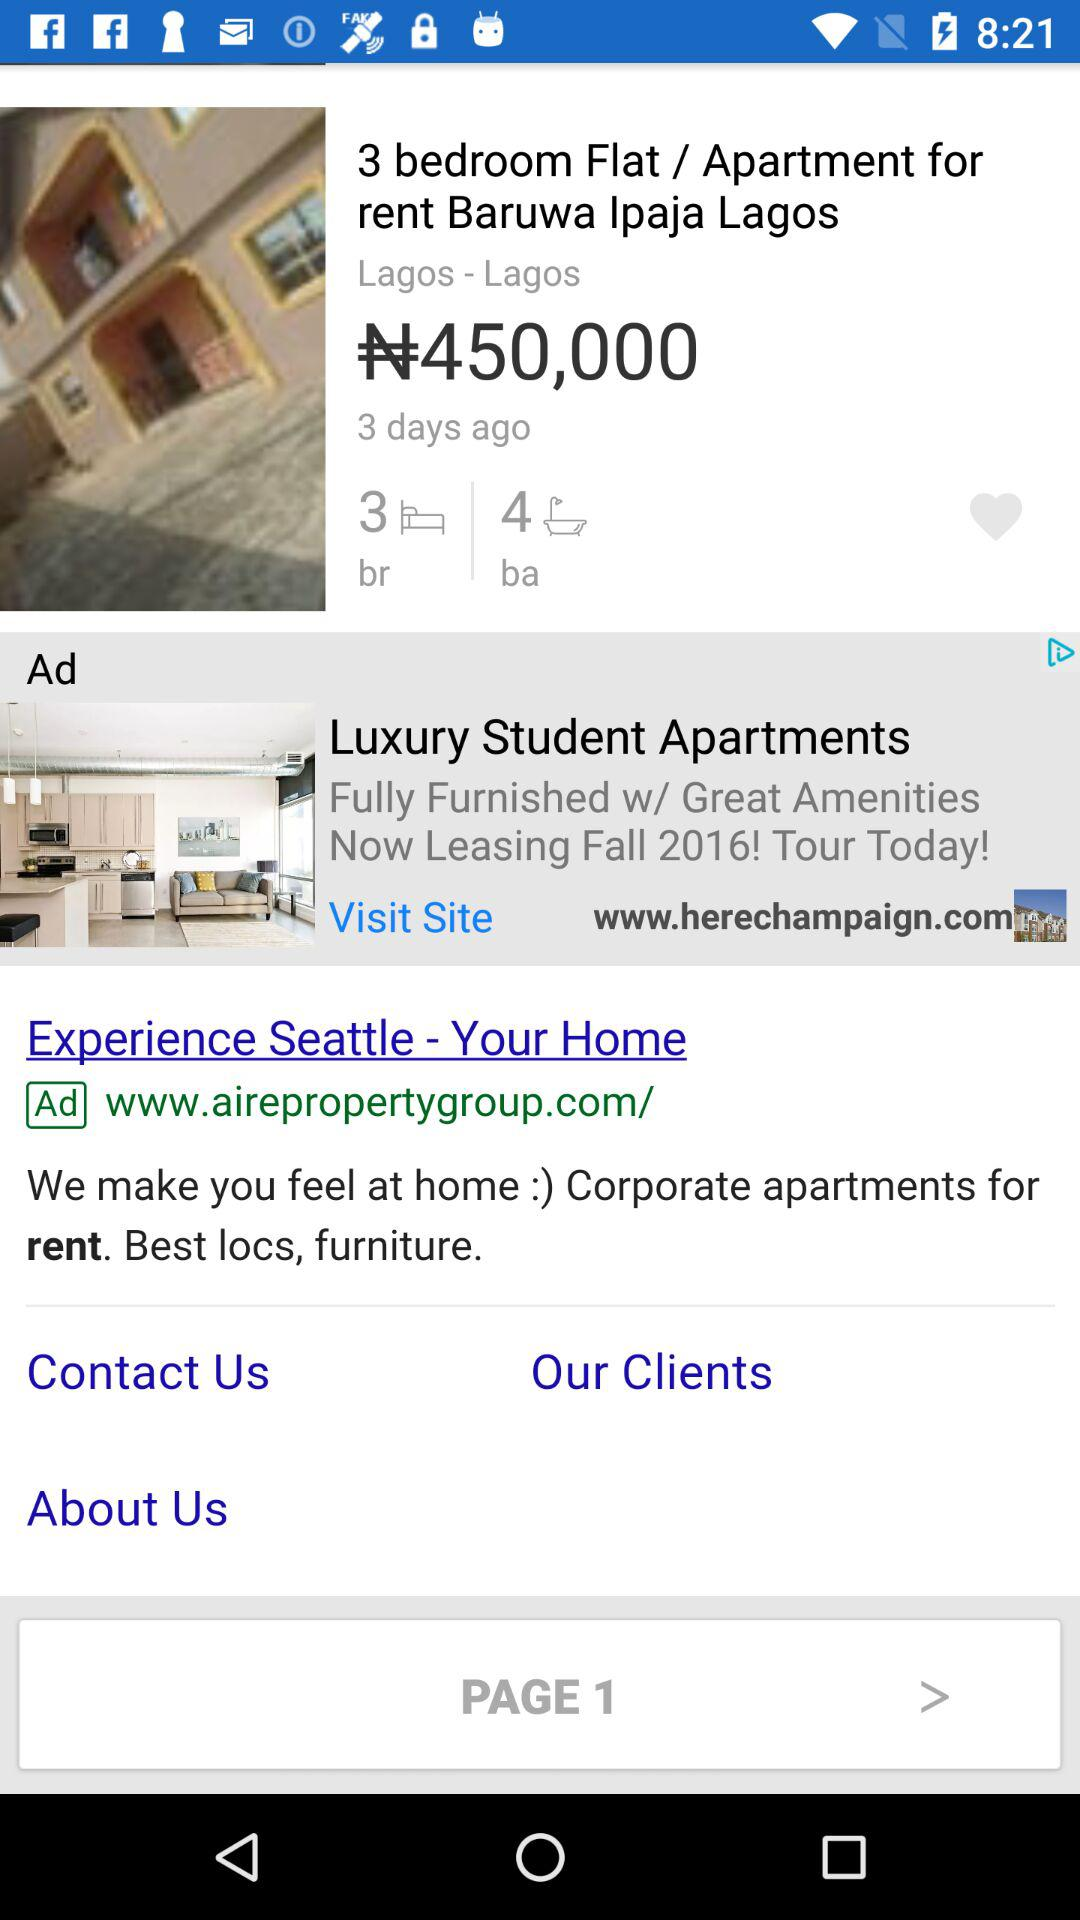How many bedrooms does the apartment have?
Answer the question using a single word or phrase. 3 